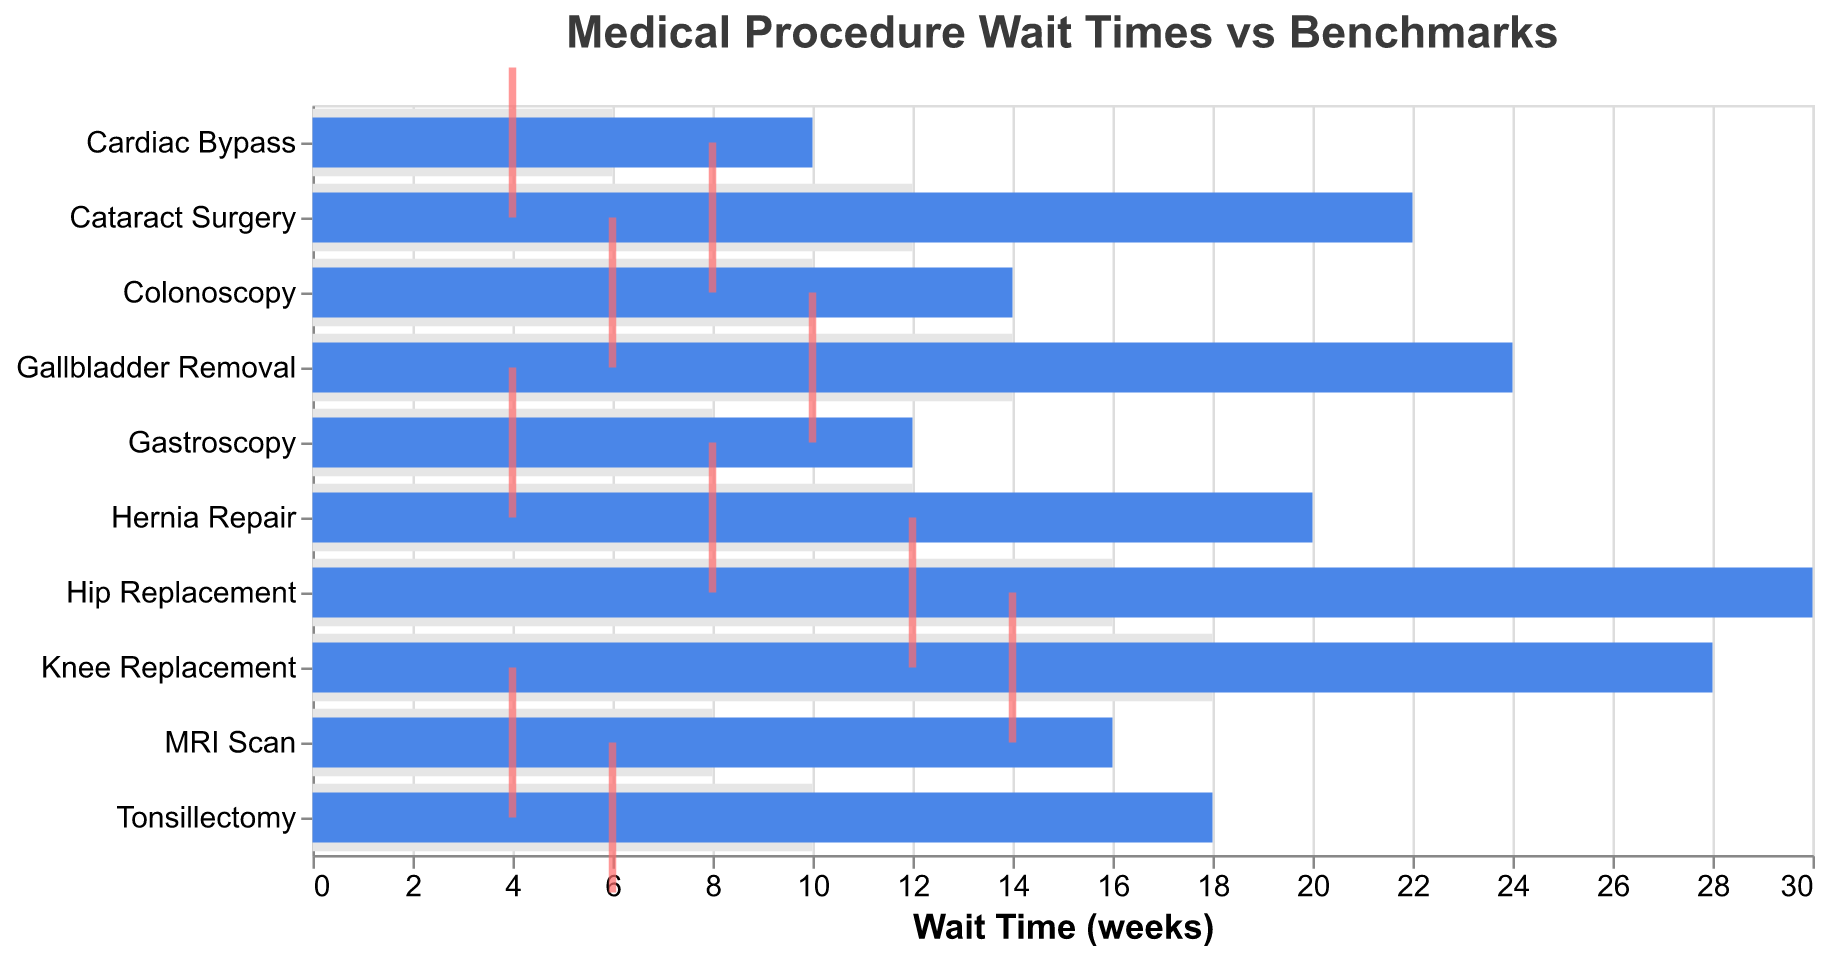How many medical procedures are listed in the chart? By counting the number of bars, which represent individual medical procedures, we can see that there are 10 different procedures.
Answer: 10 What do the red tick marks represent on the Bullet Chart? The red tick marks represent the target wait times for each medical procedure.
Answer: Target wait times What is the actual wait time for a Hip Replacement, and how does it compare to its benchmark? The bar for Hip Replacement shows an actual wait time of 30 weeks. The shaded area behind it, representing the benchmark, shows 16 weeks. So the actual wait time is 14 weeks longer than the benchmark.
Answer: 30 weeks, 14 weeks longer Which procedure has the largest difference between actual wait time and benchmark? By comparing the difference between the actual wait time and the benchmark for each procedure, Cataract Surgery has the largest difference, with an actual wait time of 22 weeks versus a benchmark of 12 weeks, resulting in a 10-week difference.
Answer: Cataract Surgery Are there any procedures where the actual wait time is less than the benchmark? For each procedure, compare the actual wait time to its benchmark. None of the procedures have an actual wait time that is less than the benchmark; all actual wait times are greater.
Answer: No What is the average benchmark wait time for all procedures listed? Sum up all the benchmark times: 16 + 18 + 12 + 6 + 8 + 10 + 8 + 12 + 10 + 14 = 114. Then divide by the number of procedures (10): 114/10 = 11.4 weeks.
Answer: 11.4 weeks How many procedures have an actual wait time that is more than double the target time? For each procedure, check if the actual wait time is more than twice the target time: Hip Replacement (30 > 12*2), Knee Replacement (28 > 14*2), Cataract Surgery (22 > 8*2), MRI Scan (16 > 4*2), Gallbladder Removal (24 > 10*2). This gives us 5 procedures.
Answer: 5 Which procedure has an actual wait time that is closest to its target? Compare the difference between the actual wait time and the target for each procedure. Cardiac Bypass shows an actual wait time of 10 weeks and a target of 4 weeks, making the difference 6 weeks, which is the closest compared to others.
Answer: Cardiac Bypass What is the total sum of all target times for the listed procedures? Add together the target times for each procedure: 12 + 14 + 8 + 4 + 4 + 6 + 4 + 8 + 6 + 10 = 76 weeks.
Answer: 76 weeks 